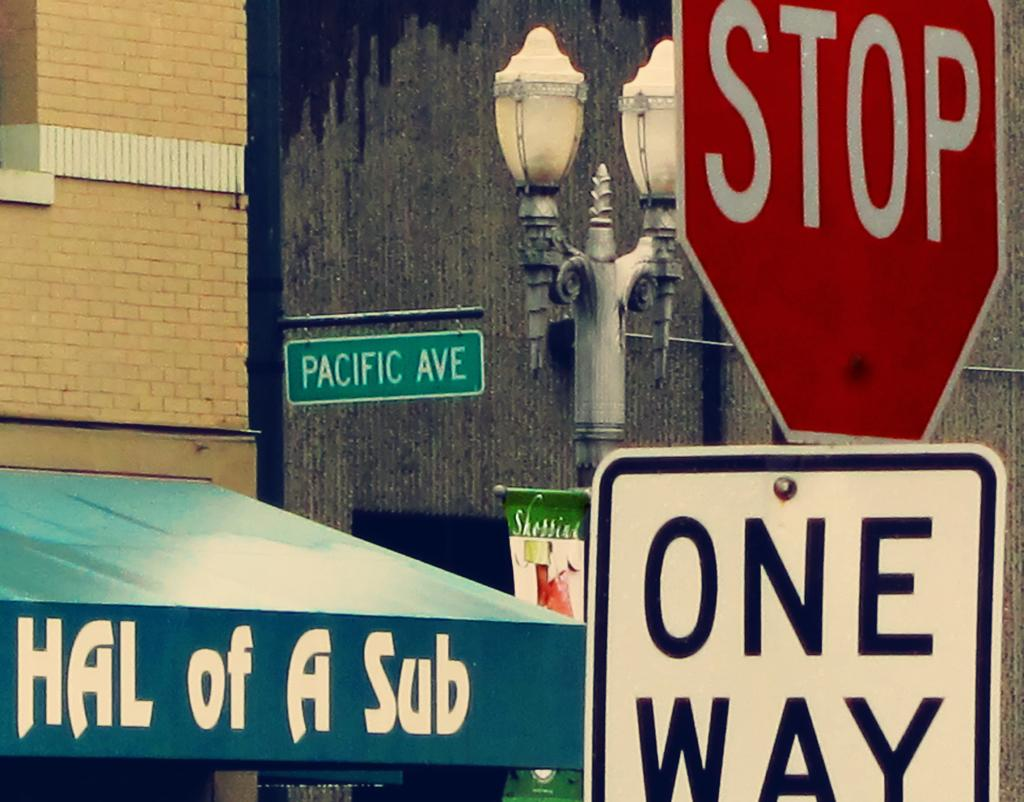<image>
Offer a succinct explanation of the picture presented. A green awning stating "Hal of a Sub" is next to a street sign for Pacific Ave, as well as a stop sign and a one way sign. 